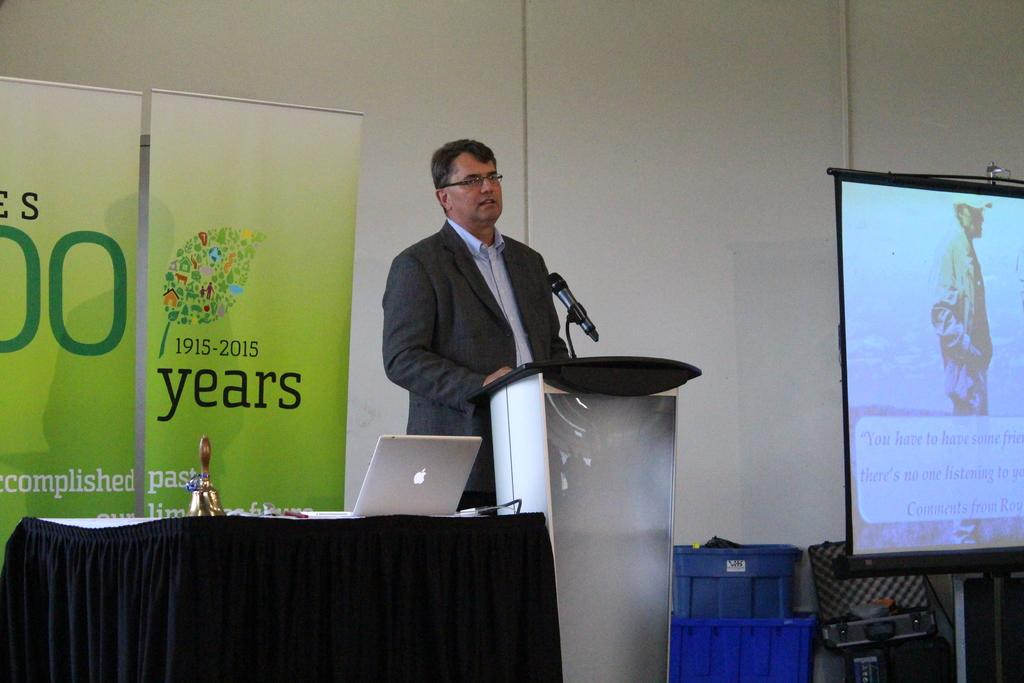<image>
Present a compact description of the photo's key features. a man standing in front of a podium with a sign reading 1915-2015 behind him 